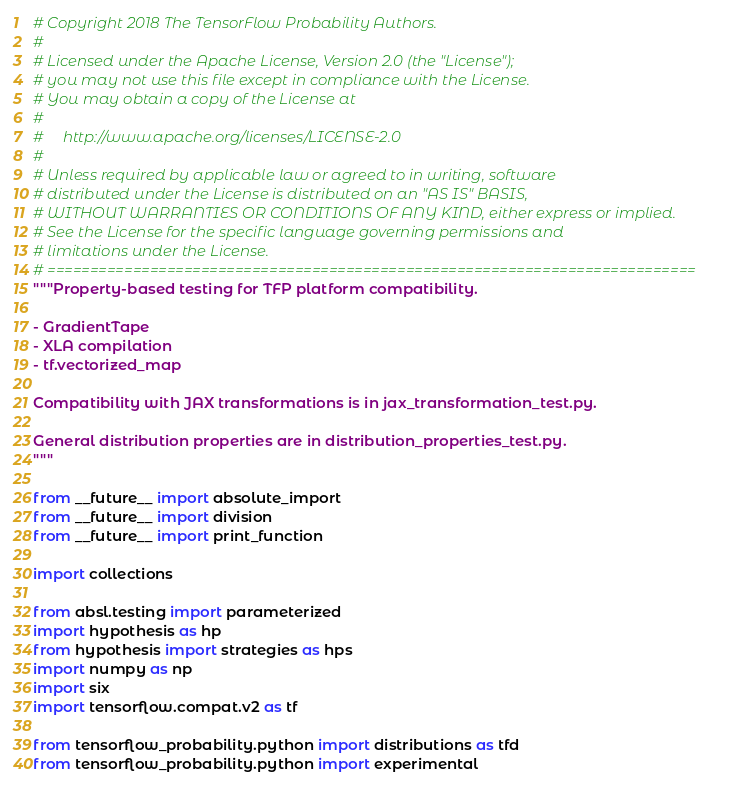Convert code to text. <code><loc_0><loc_0><loc_500><loc_500><_Python_># Copyright 2018 The TensorFlow Probability Authors.
#
# Licensed under the Apache License, Version 2.0 (the "License");
# you may not use this file except in compliance with the License.
# You may obtain a copy of the License at
#
#     http://www.apache.org/licenses/LICENSE-2.0
#
# Unless required by applicable law or agreed to in writing, software
# distributed under the License is distributed on an "AS IS" BASIS,
# WITHOUT WARRANTIES OR CONDITIONS OF ANY KIND, either express or implied.
# See the License for the specific language governing permissions and
# limitations under the License.
# ============================================================================
"""Property-based testing for TFP platform compatibility.

- GradientTape
- XLA compilation
- tf.vectorized_map

Compatibility with JAX transformations is in jax_transformation_test.py.

General distribution properties are in distribution_properties_test.py.
"""

from __future__ import absolute_import
from __future__ import division
from __future__ import print_function

import collections

from absl.testing import parameterized
import hypothesis as hp
from hypothesis import strategies as hps
import numpy as np
import six
import tensorflow.compat.v2 as tf

from tensorflow_probability.python import distributions as tfd
from tensorflow_probability.python import experimental</code> 